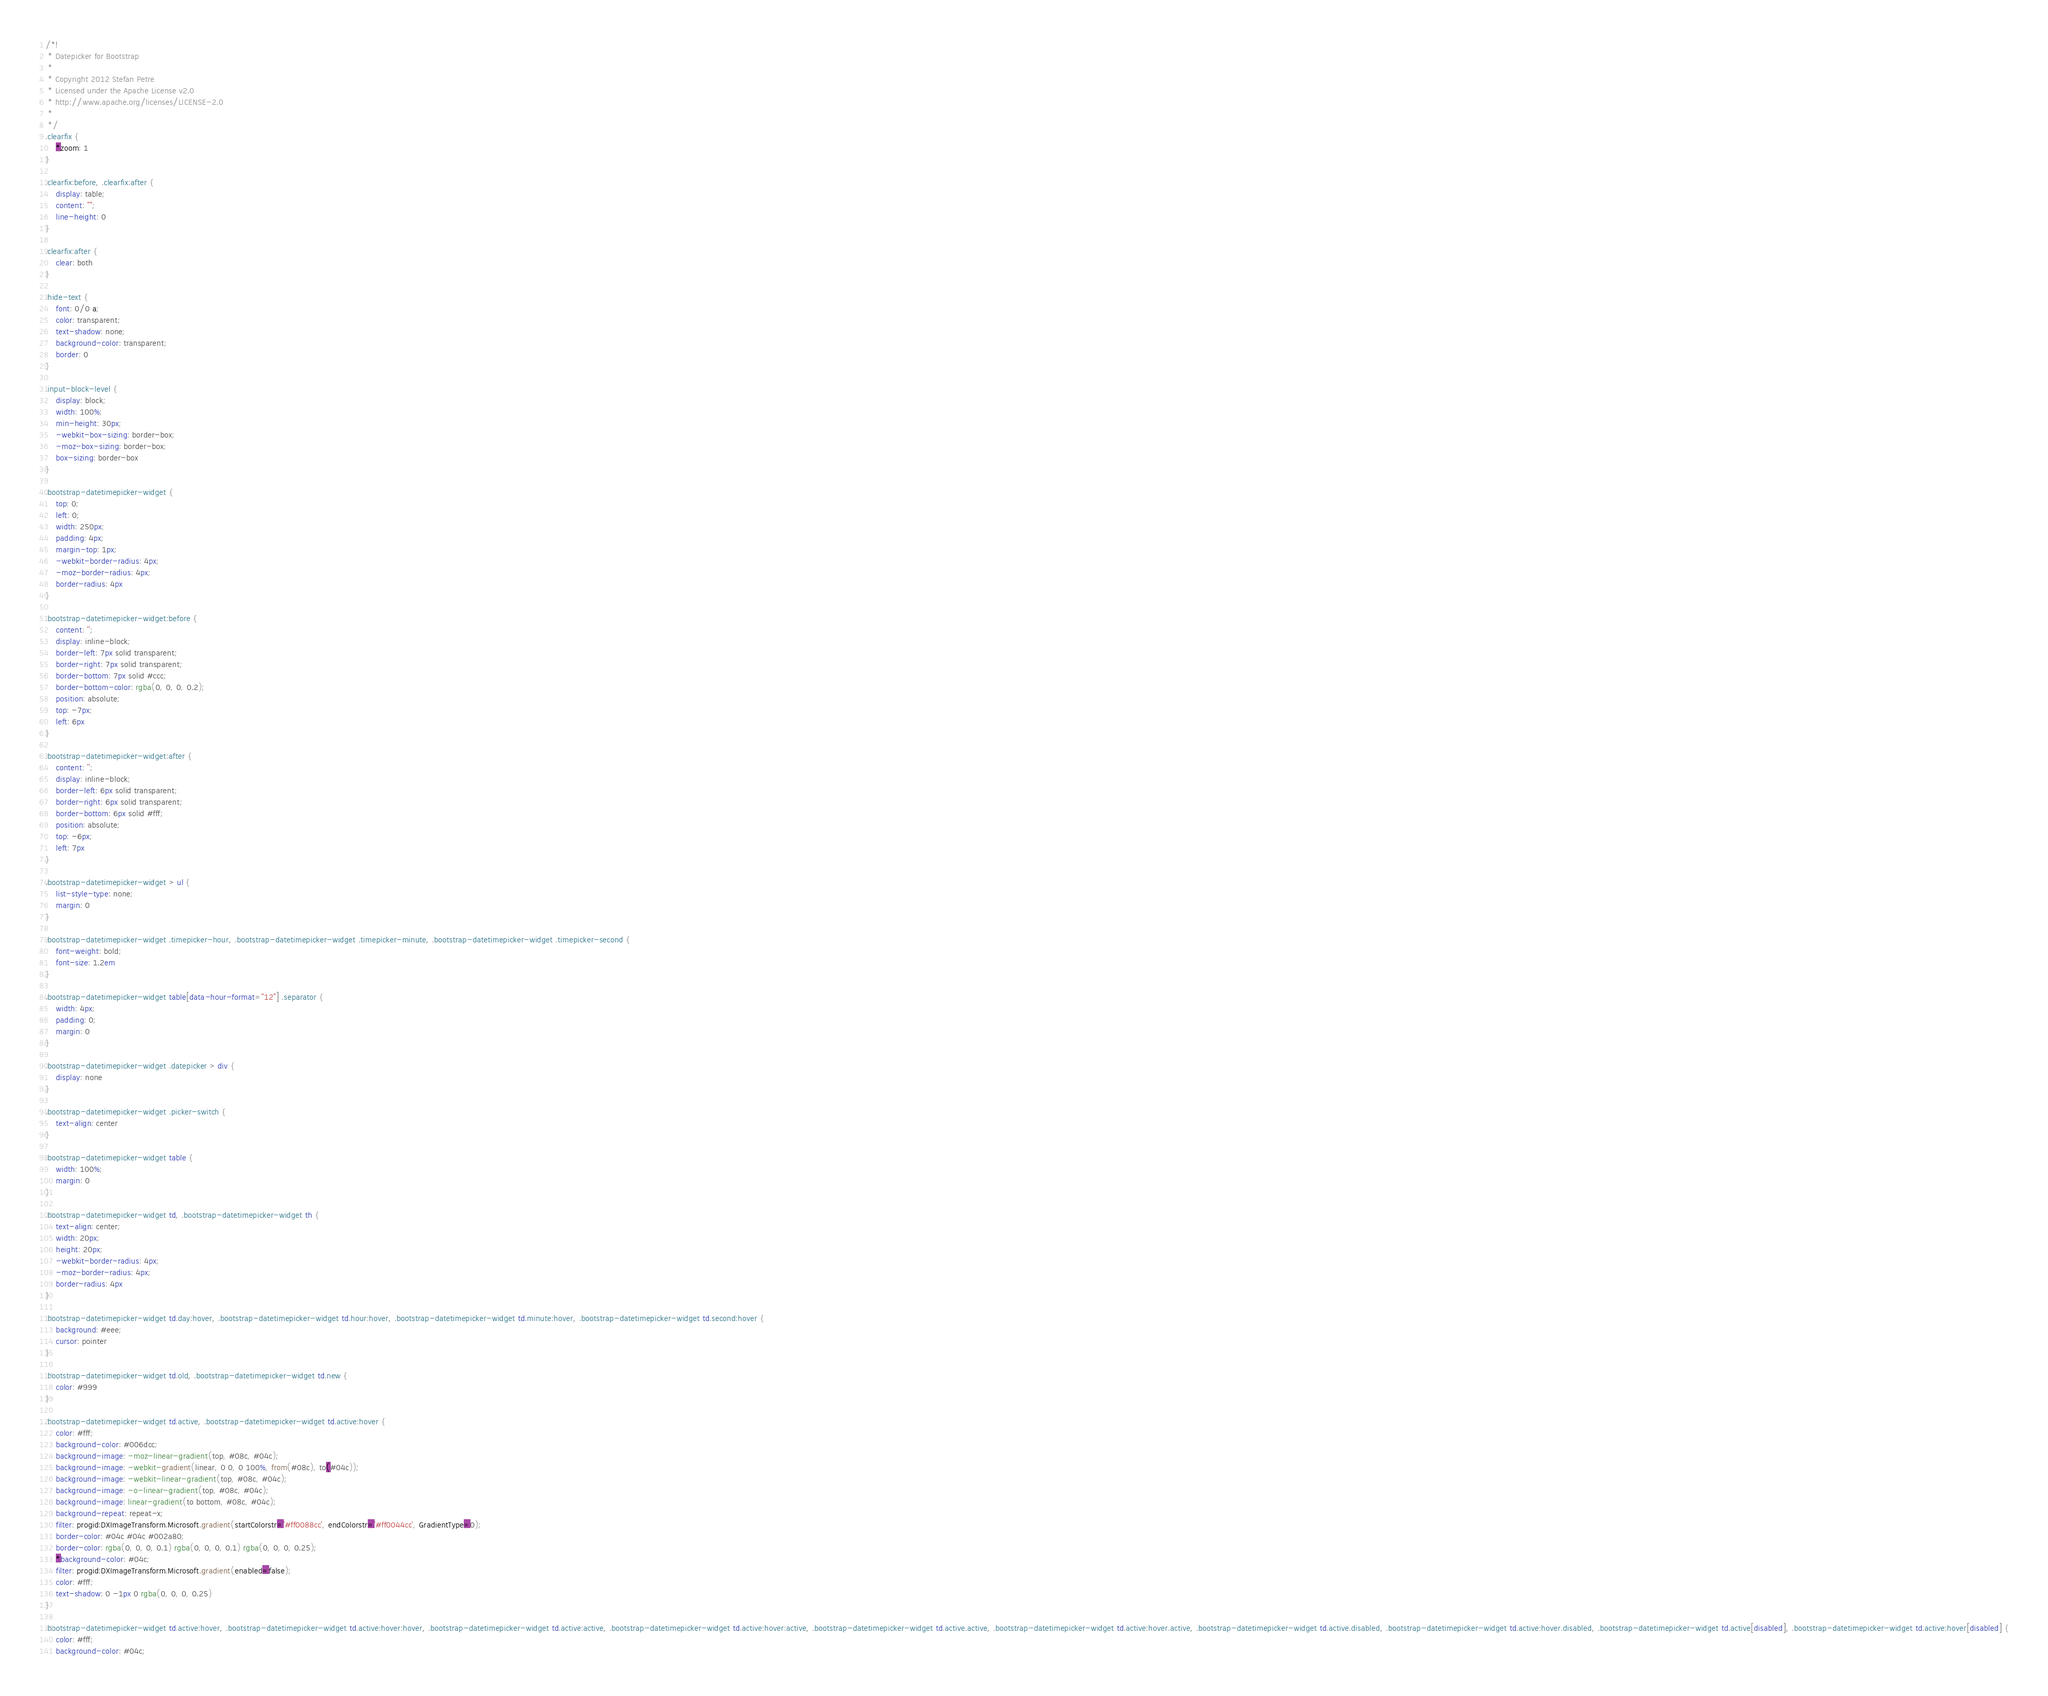<code> <loc_0><loc_0><loc_500><loc_500><_CSS_>/*!
 * Datepicker for Bootstrap
 *
 * Copyright 2012 Stefan Petre
 * Licensed under the Apache License v2.0
 * http://www.apache.org/licenses/LICENSE-2.0
 *
 */
.clearfix {
    *zoom: 1
}

.clearfix:before, .clearfix:after {
    display: table;
    content: "";
    line-height: 0
}

.clearfix:after {
    clear: both
}

.hide-text {
    font: 0/0 a;
    color: transparent;
    text-shadow: none;
    background-color: transparent;
    border: 0
}

.input-block-level {
    display: block;
    width: 100%;
    min-height: 30px;
    -webkit-box-sizing: border-box;
    -moz-box-sizing: border-box;
    box-sizing: border-box
}

.bootstrap-datetimepicker-widget {
    top: 0;
    left: 0;
    width: 250px;
    padding: 4px;
    margin-top: 1px;
    -webkit-border-radius: 4px;
    -moz-border-radius: 4px;
    border-radius: 4px
}

.bootstrap-datetimepicker-widget:before {
    content: '';
    display: inline-block;
    border-left: 7px solid transparent;
    border-right: 7px solid transparent;
    border-bottom: 7px solid #ccc;
    border-bottom-color: rgba(0, 0, 0, 0.2);
    position: absolute;
    top: -7px;
    left: 6px
}

.bootstrap-datetimepicker-widget:after {
    content: '';
    display: inline-block;
    border-left: 6px solid transparent;
    border-right: 6px solid transparent;
    border-bottom: 6px solid #fff;
    position: absolute;
    top: -6px;
    left: 7px
}

.bootstrap-datetimepicker-widget > ul {
    list-style-type: none;
    margin: 0
}

.bootstrap-datetimepicker-widget .timepicker-hour, .bootstrap-datetimepicker-widget .timepicker-minute, .bootstrap-datetimepicker-widget .timepicker-second {
    font-weight: bold;
    font-size: 1.2em
}

.bootstrap-datetimepicker-widget table[data-hour-format="12"] .separator {
    width: 4px;
    padding: 0;
    margin: 0
}

.bootstrap-datetimepicker-widget .datepicker > div {
    display: none
}

.bootstrap-datetimepicker-widget .picker-switch {
    text-align: center
}

.bootstrap-datetimepicker-widget table {
    width: 100%;
    margin: 0
}

.bootstrap-datetimepicker-widget td, .bootstrap-datetimepicker-widget th {
    text-align: center;
    width: 20px;
    height: 20px;
    -webkit-border-radius: 4px;
    -moz-border-radius: 4px;
    border-radius: 4px
}

.bootstrap-datetimepicker-widget td.day:hover, .bootstrap-datetimepicker-widget td.hour:hover, .bootstrap-datetimepicker-widget td.minute:hover, .bootstrap-datetimepicker-widget td.second:hover {
    background: #eee;
    cursor: pointer
}

.bootstrap-datetimepicker-widget td.old, .bootstrap-datetimepicker-widget td.new {
    color: #999
}

.bootstrap-datetimepicker-widget td.active, .bootstrap-datetimepicker-widget td.active:hover {
    color: #fff;
    background-color: #006dcc;
    background-image: -moz-linear-gradient(top, #08c, #04c);
    background-image: -webkit-gradient(linear, 0 0, 0 100%, from(#08c), to(#04c));
    background-image: -webkit-linear-gradient(top, #08c, #04c);
    background-image: -o-linear-gradient(top, #08c, #04c);
    background-image: linear-gradient(to bottom, #08c, #04c);
    background-repeat: repeat-x;
    filter: progid:DXImageTransform.Microsoft.gradient(startColorstr='#ff0088cc', endColorstr='#ff0044cc', GradientType=0);
    border-color: #04c #04c #002a80;
    border-color: rgba(0, 0, 0, 0.1) rgba(0, 0, 0, 0.1) rgba(0, 0, 0, 0.25);
    *background-color: #04c;
    filter: progid:DXImageTransform.Microsoft.gradient(enabled=false);
    color: #fff;
    text-shadow: 0 -1px 0 rgba(0, 0, 0, 0.25)
}

.bootstrap-datetimepicker-widget td.active:hover, .bootstrap-datetimepicker-widget td.active:hover:hover, .bootstrap-datetimepicker-widget td.active:active, .bootstrap-datetimepicker-widget td.active:hover:active, .bootstrap-datetimepicker-widget td.active.active, .bootstrap-datetimepicker-widget td.active:hover.active, .bootstrap-datetimepicker-widget td.active.disabled, .bootstrap-datetimepicker-widget td.active:hover.disabled, .bootstrap-datetimepicker-widget td.active[disabled], .bootstrap-datetimepicker-widget td.active:hover[disabled] {
    color: #fff;
    background-color: #04c;</code> 